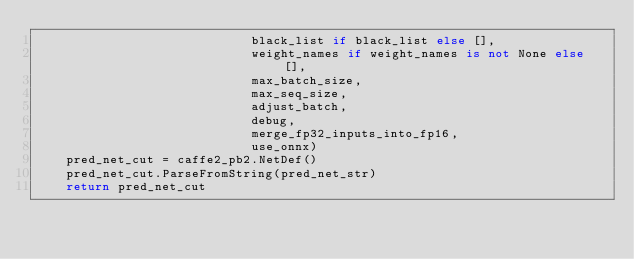Convert code to text. <code><loc_0><loc_0><loc_500><loc_500><_Python_>                             black_list if black_list else [],
                             weight_names if weight_names is not None else [],
                             max_batch_size,
                             max_seq_size,
                             adjust_batch,
                             debug,
                             merge_fp32_inputs_into_fp16,
                             use_onnx)
    pred_net_cut = caffe2_pb2.NetDef()
    pred_net_cut.ParseFromString(pred_net_str)
    return pred_net_cut
</code> 